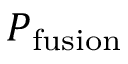Convert formula to latex. <formula><loc_0><loc_0><loc_500><loc_500>P _ { f u s i o n }</formula> 